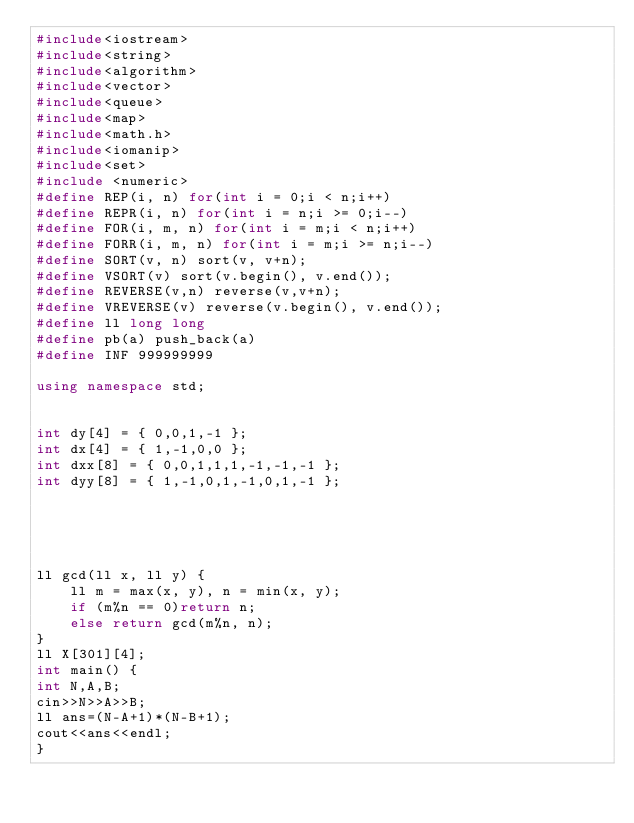<code> <loc_0><loc_0><loc_500><loc_500><_C++_>#include<iostream>
#include<string>
#include<algorithm>
#include<vector>
#include<queue>
#include<map>
#include<math.h>
#include<iomanip>
#include<set>
#include <numeric>
#define REP(i, n) for(int i = 0;i < n;i++)
#define REPR(i, n) for(int i = n;i >= 0;i--)
#define FOR(i, m, n) for(int i = m;i < n;i++)
#define FORR(i, m, n) for(int i = m;i >= n;i--)
#define SORT(v, n) sort(v, v+n);
#define VSORT(v) sort(v.begin(), v.end());
#define REVERSE(v,n) reverse(v,v+n);
#define VREVERSE(v) reverse(v.begin(), v.end());
#define ll long long
#define pb(a) push_back(a)
#define INF 999999999

using namespace std;


int dy[4] = { 0,0,1,-1 };
int dx[4] = { 1,-1,0,0 };
int dxx[8] = { 0,0,1,1,1,-1,-1,-1 };
int dyy[8] = { 1,-1,0,1,-1,0,1,-1 };





ll gcd(ll x, ll y) {
	ll m = max(x, y), n = min(x, y);
	if (m%n == 0)return n;
	else return gcd(m%n, n);
}
ll X[301][4];
int main() {
int N,A,B;
cin>>N>>A>>B;
ll ans=(N-A+1)*(N-B+1);
cout<<ans<<endl; 
}
</code> 